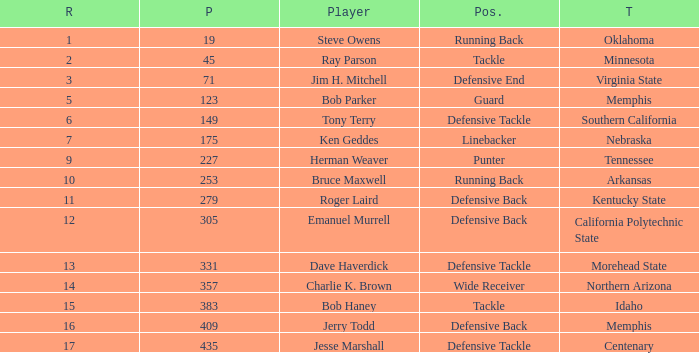What is the average pick of player jim h. mitchell? 71.0. 